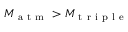<formula> <loc_0><loc_0><loc_500><loc_500>M _ { a t m } > M _ { t r i p l e }</formula> 